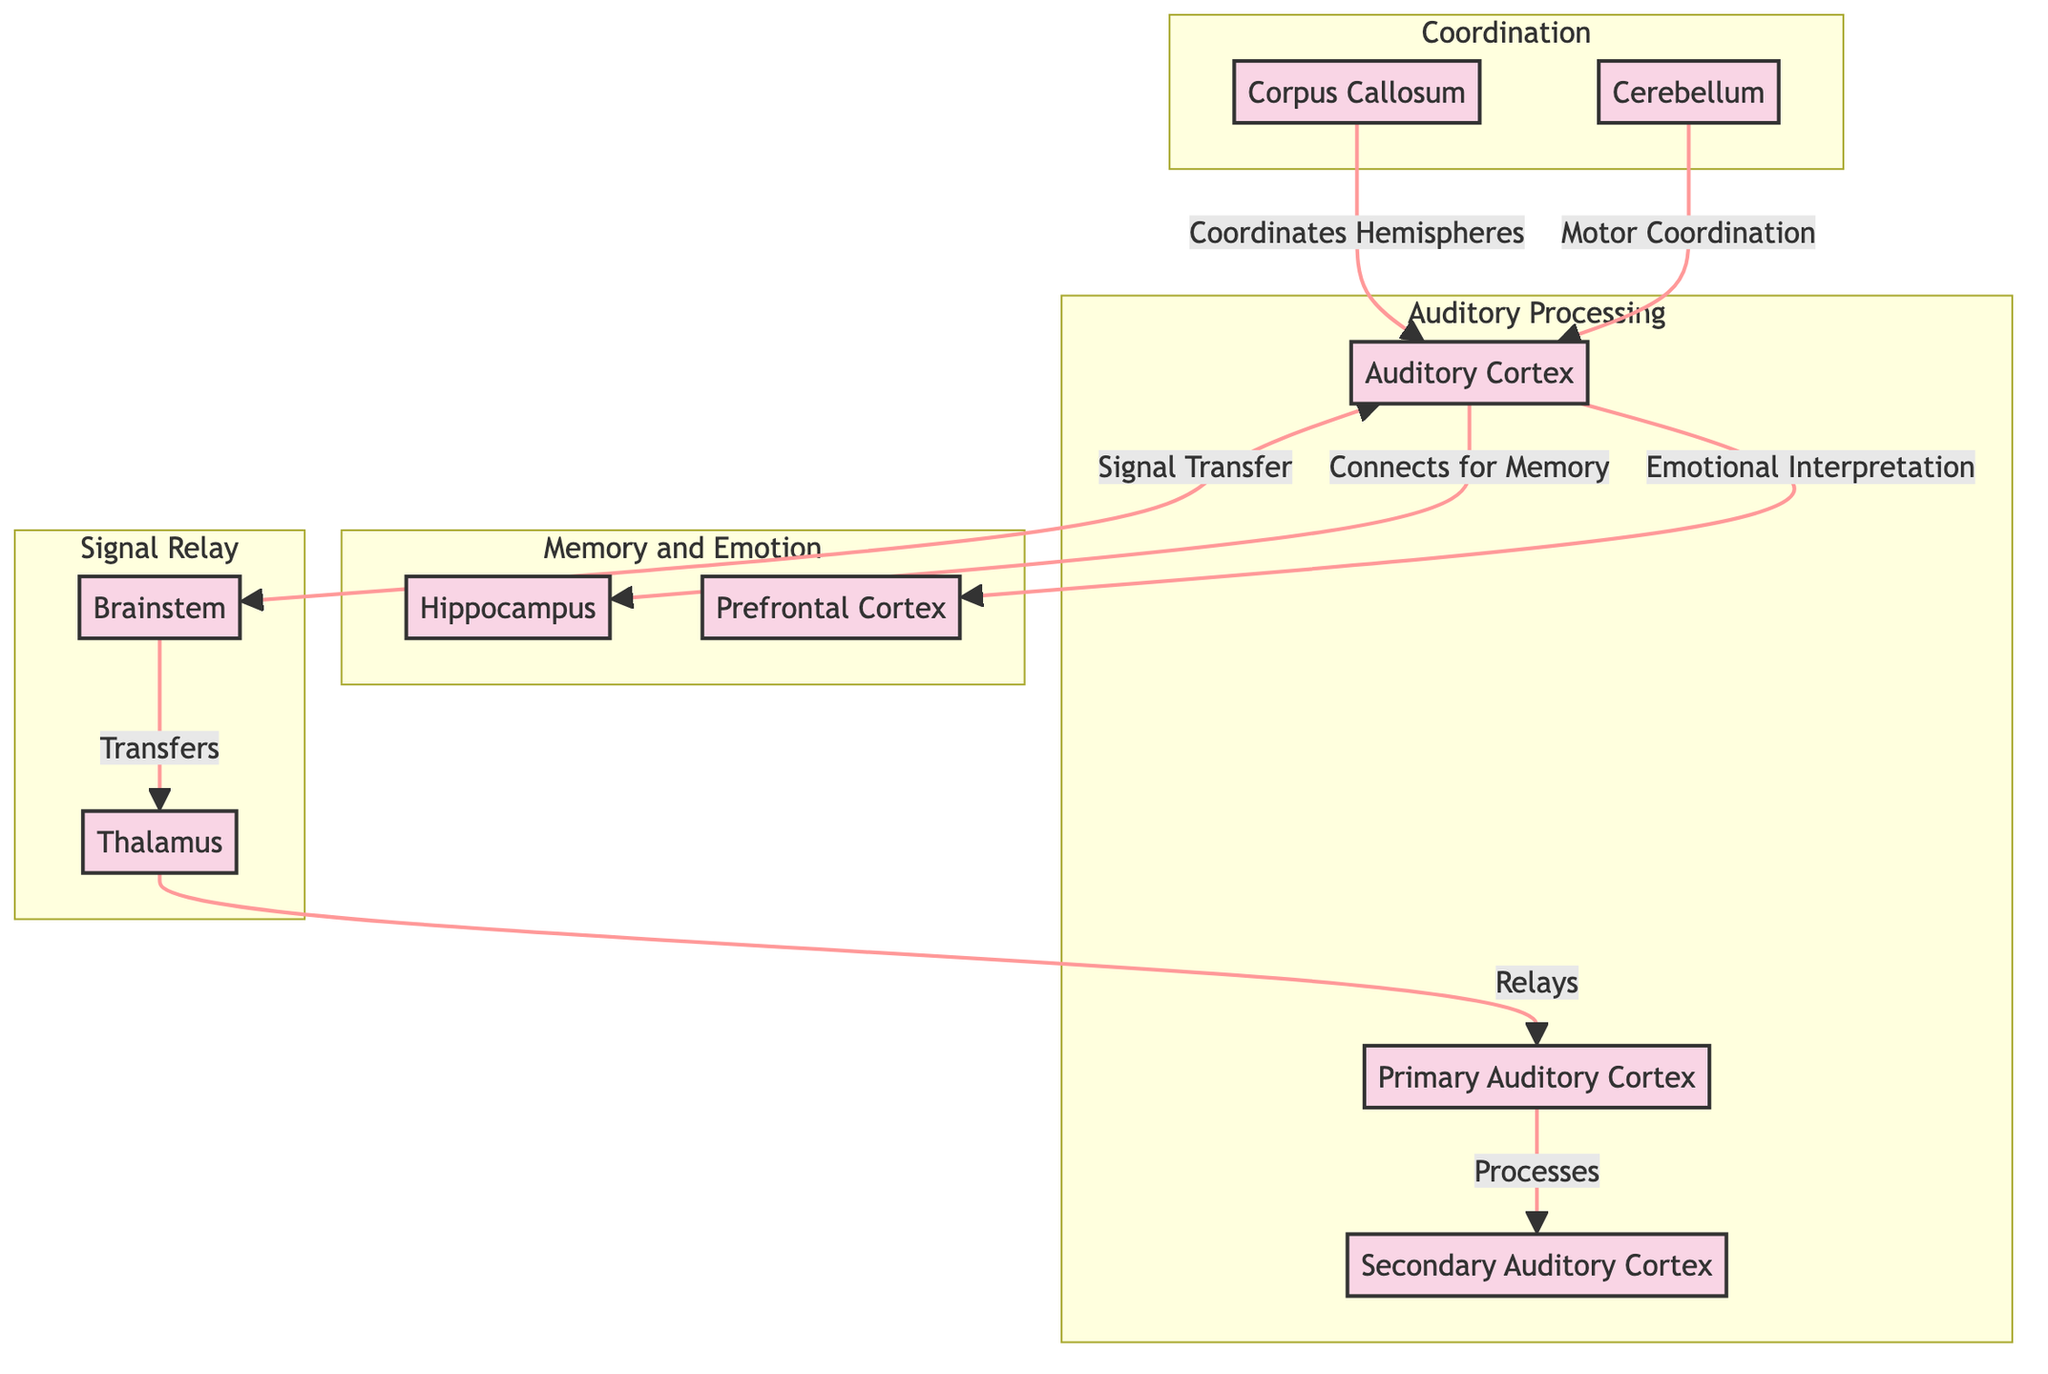What is the role of the Thalamus in this diagram? The Thalamus relays signals from the Brainstem to the Primary Auditory Cortex, indicating its crucial role in auditory information processing.
Answer: Relays How many brain regions are involved in auditory processing according to the diagram? The diagram highlights three main regions involved in auditory processing: the Auditory Cortex, Primary Auditory Cortex, and Secondary Auditory Cortex.
Answer: Three What connects the two hemispheres of the brain as shown in the diagram? The Corpus Callosum is indicated as the structure that coordinates communication between the hemispheres and connects to the Auditory Cortex.
Answer: Corpus Callosum Which brain region is primarily responsible for emotional interpretation related to sound? The Prefrontal Cortex is connected to the Auditory Cortex and plays a significant role in emotional interpretation.
Answer: Prefrontal Cortex How does the Auditory Cortex interact with the Hippocampus according to the diagram? The Auditory Cortex connects to the Hippocampus for memory processing, indicating its involvement in relating sound to memories.
Answer: Connects for Memory What is the function of the Cerebellum in relation to the Auditory Cortex? The Cerebellum is shown to coordinate motor activities that may relate to the auditory experiences processed in the Auditory Cortex.
Answer: Motor Coordination In which subgraph is the Primary Auditory Cortex located? The Primary Auditory Cortex is located in the "Auditory Processing" subgraph, emphasizing its role in processing auditory information.
Answer: Auditory Processing What is the direction of signal transfer from the Brainstem to the Auditory Cortex? The signal transfer from the Brainstem to the Auditory Cortex occurs in the sequence of Brainstem to Thalamus, then to Primary Auditory Cortex.
Answer: Transfers Which region connects auditory processing with memory functions? The Auditory Cortex connects with the Hippocampus, linking auditory processing to memory functions in the brain.
Answer: Auditory Cortex 